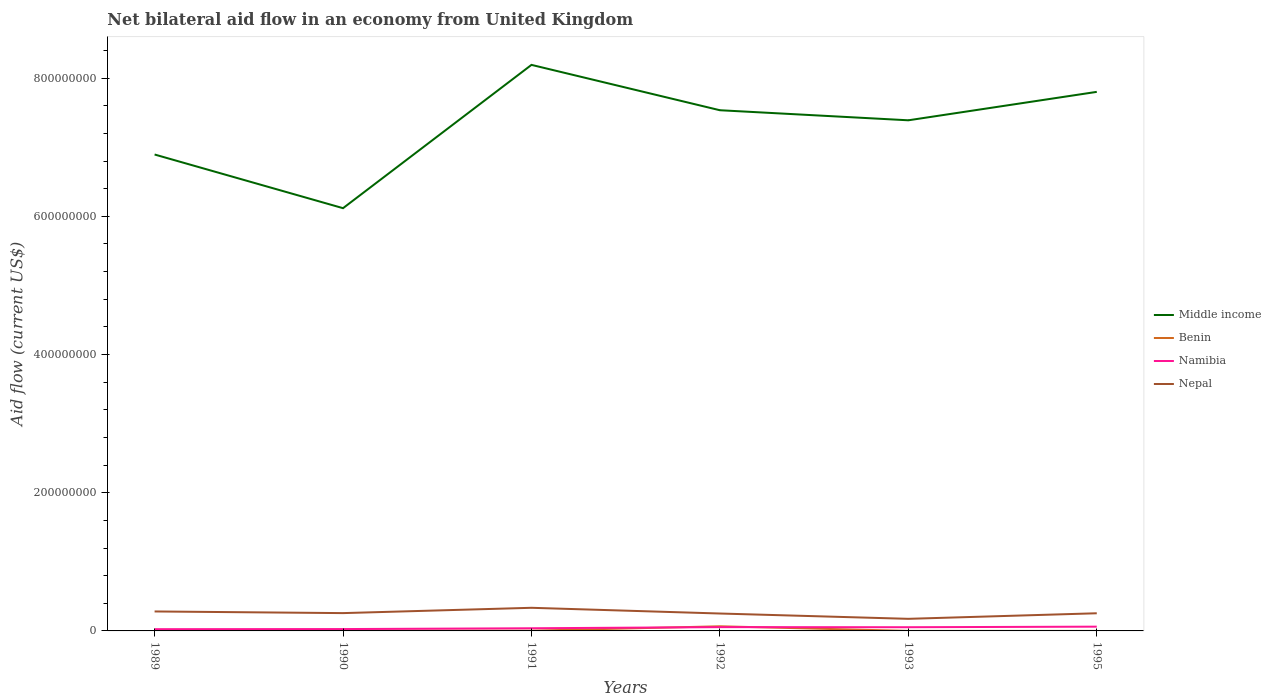How many different coloured lines are there?
Provide a short and direct response. 4. Across all years, what is the maximum net bilateral aid flow in Namibia?
Your response must be concise. 2.53e+06. In which year was the net bilateral aid flow in Benin maximum?
Your answer should be compact. 1995. What is the difference between the highest and the second highest net bilateral aid flow in Nepal?
Give a very brief answer. 1.60e+07. What is the difference between the highest and the lowest net bilateral aid flow in Middle income?
Offer a terse response. 4. What is the difference between two consecutive major ticks on the Y-axis?
Your response must be concise. 2.00e+08. Are the values on the major ticks of Y-axis written in scientific E-notation?
Keep it short and to the point. No. Does the graph contain any zero values?
Provide a succinct answer. No. Does the graph contain grids?
Provide a succinct answer. No. Where does the legend appear in the graph?
Make the answer very short. Center right. How many legend labels are there?
Ensure brevity in your answer.  4. How are the legend labels stacked?
Your response must be concise. Vertical. What is the title of the graph?
Your response must be concise. Net bilateral aid flow in an economy from United Kingdom. Does "Togo" appear as one of the legend labels in the graph?
Provide a succinct answer. No. What is the label or title of the X-axis?
Make the answer very short. Years. What is the label or title of the Y-axis?
Offer a terse response. Aid flow (current US$). What is the Aid flow (current US$) in Middle income in 1989?
Your response must be concise. 6.89e+08. What is the Aid flow (current US$) of Benin in 1989?
Make the answer very short. 5.40e+05. What is the Aid flow (current US$) of Namibia in 1989?
Make the answer very short. 2.53e+06. What is the Aid flow (current US$) of Nepal in 1989?
Your response must be concise. 2.82e+07. What is the Aid flow (current US$) of Middle income in 1990?
Your answer should be very brief. 6.12e+08. What is the Aid flow (current US$) of Benin in 1990?
Provide a short and direct response. 5.60e+05. What is the Aid flow (current US$) in Namibia in 1990?
Offer a terse response. 2.70e+06. What is the Aid flow (current US$) of Nepal in 1990?
Your answer should be compact. 2.58e+07. What is the Aid flow (current US$) of Middle income in 1991?
Your answer should be compact. 8.19e+08. What is the Aid flow (current US$) of Benin in 1991?
Give a very brief answer. 3.40e+05. What is the Aid flow (current US$) in Namibia in 1991?
Make the answer very short. 3.85e+06. What is the Aid flow (current US$) in Nepal in 1991?
Your answer should be very brief. 3.35e+07. What is the Aid flow (current US$) of Middle income in 1992?
Ensure brevity in your answer.  7.54e+08. What is the Aid flow (current US$) of Benin in 1992?
Offer a terse response. 6.70e+06. What is the Aid flow (current US$) of Namibia in 1992?
Ensure brevity in your answer.  5.49e+06. What is the Aid flow (current US$) in Nepal in 1992?
Your answer should be very brief. 2.52e+07. What is the Aid flow (current US$) in Middle income in 1993?
Offer a terse response. 7.39e+08. What is the Aid flow (current US$) in Namibia in 1993?
Your answer should be compact. 5.35e+06. What is the Aid flow (current US$) of Nepal in 1993?
Your answer should be compact. 1.75e+07. What is the Aid flow (current US$) of Middle income in 1995?
Your response must be concise. 7.80e+08. What is the Aid flow (current US$) of Namibia in 1995?
Make the answer very short. 6.18e+06. What is the Aid flow (current US$) of Nepal in 1995?
Ensure brevity in your answer.  2.56e+07. Across all years, what is the maximum Aid flow (current US$) of Middle income?
Provide a succinct answer. 8.19e+08. Across all years, what is the maximum Aid flow (current US$) in Benin?
Offer a terse response. 6.70e+06. Across all years, what is the maximum Aid flow (current US$) in Namibia?
Your answer should be very brief. 6.18e+06. Across all years, what is the maximum Aid flow (current US$) in Nepal?
Keep it short and to the point. 3.35e+07. Across all years, what is the minimum Aid flow (current US$) in Middle income?
Offer a terse response. 6.12e+08. Across all years, what is the minimum Aid flow (current US$) in Namibia?
Make the answer very short. 2.53e+06. Across all years, what is the minimum Aid flow (current US$) of Nepal?
Make the answer very short. 1.75e+07. What is the total Aid flow (current US$) of Middle income in the graph?
Offer a very short reply. 4.39e+09. What is the total Aid flow (current US$) of Benin in the graph?
Your response must be concise. 8.21e+06. What is the total Aid flow (current US$) of Namibia in the graph?
Make the answer very short. 2.61e+07. What is the total Aid flow (current US$) of Nepal in the graph?
Keep it short and to the point. 1.56e+08. What is the difference between the Aid flow (current US$) of Middle income in 1989 and that in 1990?
Provide a short and direct response. 7.77e+07. What is the difference between the Aid flow (current US$) in Namibia in 1989 and that in 1990?
Provide a succinct answer. -1.70e+05. What is the difference between the Aid flow (current US$) of Nepal in 1989 and that in 1990?
Your answer should be very brief. 2.40e+06. What is the difference between the Aid flow (current US$) in Middle income in 1989 and that in 1991?
Give a very brief answer. -1.30e+08. What is the difference between the Aid flow (current US$) of Benin in 1989 and that in 1991?
Offer a very short reply. 2.00e+05. What is the difference between the Aid flow (current US$) in Namibia in 1989 and that in 1991?
Make the answer very short. -1.32e+06. What is the difference between the Aid flow (current US$) of Nepal in 1989 and that in 1991?
Your answer should be very brief. -5.29e+06. What is the difference between the Aid flow (current US$) of Middle income in 1989 and that in 1992?
Your answer should be compact. -6.41e+07. What is the difference between the Aid flow (current US$) of Benin in 1989 and that in 1992?
Offer a terse response. -6.16e+06. What is the difference between the Aid flow (current US$) of Namibia in 1989 and that in 1992?
Offer a very short reply. -2.96e+06. What is the difference between the Aid flow (current US$) in Middle income in 1989 and that in 1993?
Give a very brief answer. -4.95e+07. What is the difference between the Aid flow (current US$) of Namibia in 1989 and that in 1993?
Your answer should be very brief. -2.82e+06. What is the difference between the Aid flow (current US$) in Nepal in 1989 and that in 1993?
Your response must be concise. 1.07e+07. What is the difference between the Aid flow (current US$) of Middle income in 1989 and that in 1995?
Ensure brevity in your answer.  -9.06e+07. What is the difference between the Aid flow (current US$) in Benin in 1989 and that in 1995?
Keep it short and to the point. 5.20e+05. What is the difference between the Aid flow (current US$) in Namibia in 1989 and that in 1995?
Provide a short and direct response. -3.65e+06. What is the difference between the Aid flow (current US$) in Nepal in 1989 and that in 1995?
Your answer should be compact. 2.63e+06. What is the difference between the Aid flow (current US$) in Middle income in 1990 and that in 1991?
Offer a terse response. -2.07e+08. What is the difference between the Aid flow (current US$) in Benin in 1990 and that in 1991?
Offer a terse response. 2.20e+05. What is the difference between the Aid flow (current US$) of Namibia in 1990 and that in 1991?
Your response must be concise. -1.15e+06. What is the difference between the Aid flow (current US$) in Nepal in 1990 and that in 1991?
Provide a succinct answer. -7.69e+06. What is the difference between the Aid flow (current US$) of Middle income in 1990 and that in 1992?
Provide a short and direct response. -1.42e+08. What is the difference between the Aid flow (current US$) in Benin in 1990 and that in 1992?
Your response must be concise. -6.14e+06. What is the difference between the Aid flow (current US$) of Namibia in 1990 and that in 1992?
Provide a succinct answer. -2.79e+06. What is the difference between the Aid flow (current US$) of Nepal in 1990 and that in 1992?
Your answer should be compact. 6.00e+05. What is the difference between the Aid flow (current US$) in Middle income in 1990 and that in 1993?
Provide a short and direct response. -1.27e+08. What is the difference between the Aid flow (current US$) of Benin in 1990 and that in 1993?
Your answer should be compact. 5.10e+05. What is the difference between the Aid flow (current US$) in Namibia in 1990 and that in 1993?
Your answer should be compact. -2.65e+06. What is the difference between the Aid flow (current US$) of Nepal in 1990 and that in 1993?
Keep it short and to the point. 8.28e+06. What is the difference between the Aid flow (current US$) of Middle income in 1990 and that in 1995?
Your response must be concise. -1.68e+08. What is the difference between the Aid flow (current US$) of Benin in 1990 and that in 1995?
Make the answer very short. 5.40e+05. What is the difference between the Aid flow (current US$) in Namibia in 1990 and that in 1995?
Your answer should be compact. -3.48e+06. What is the difference between the Aid flow (current US$) of Nepal in 1990 and that in 1995?
Provide a short and direct response. 2.30e+05. What is the difference between the Aid flow (current US$) of Middle income in 1991 and that in 1992?
Make the answer very short. 6.56e+07. What is the difference between the Aid flow (current US$) of Benin in 1991 and that in 1992?
Offer a terse response. -6.36e+06. What is the difference between the Aid flow (current US$) of Namibia in 1991 and that in 1992?
Ensure brevity in your answer.  -1.64e+06. What is the difference between the Aid flow (current US$) of Nepal in 1991 and that in 1992?
Give a very brief answer. 8.29e+06. What is the difference between the Aid flow (current US$) in Middle income in 1991 and that in 1993?
Keep it short and to the point. 8.02e+07. What is the difference between the Aid flow (current US$) in Benin in 1991 and that in 1993?
Your answer should be very brief. 2.90e+05. What is the difference between the Aid flow (current US$) of Namibia in 1991 and that in 1993?
Keep it short and to the point. -1.50e+06. What is the difference between the Aid flow (current US$) in Nepal in 1991 and that in 1993?
Keep it short and to the point. 1.60e+07. What is the difference between the Aid flow (current US$) of Middle income in 1991 and that in 1995?
Offer a very short reply. 3.91e+07. What is the difference between the Aid flow (current US$) of Benin in 1991 and that in 1995?
Ensure brevity in your answer.  3.20e+05. What is the difference between the Aid flow (current US$) of Namibia in 1991 and that in 1995?
Give a very brief answer. -2.33e+06. What is the difference between the Aid flow (current US$) in Nepal in 1991 and that in 1995?
Offer a terse response. 7.92e+06. What is the difference between the Aid flow (current US$) of Middle income in 1992 and that in 1993?
Offer a very short reply. 1.46e+07. What is the difference between the Aid flow (current US$) in Benin in 1992 and that in 1993?
Your response must be concise. 6.65e+06. What is the difference between the Aid flow (current US$) in Namibia in 1992 and that in 1993?
Give a very brief answer. 1.40e+05. What is the difference between the Aid flow (current US$) in Nepal in 1992 and that in 1993?
Your response must be concise. 7.68e+06. What is the difference between the Aid flow (current US$) of Middle income in 1992 and that in 1995?
Your answer should be very brief. -2.66e+07. What is the difference between the Aid flow (current US$) in Benin in 1992 and that in 1995?
Give a very brief answer. 6.68e+06. What is the difference between the Aid flow (current US$) of Namibia in 1992 and that in 1995?
Provide a succinct answer. -6.90e+05. What is the difference between the Aid flow (current US$) of Nepal in 1992 and that in 1995?
Give a very brief answer. -3.70e+05. What is the difference between the Aid flow (current US$) in Middle income in 1993 and that in 1995?
Your answer should be very brief. -4.11e+07. What is the difference between the Aid flow (current US$) of Namibia in 1993 and that in 1995?
Offer a very short reply. -8.30e+05. What is the difference between the Aid flow (current US$) in Nepal in 1993 and that in 1995?
Give a very brief answer. -8.05e+06. What is the difference between the Aid flow (current US$) of Middle income in 1989 and the Aid flow (current US$) of Benin in 1990?
Your answer should be compact. 6.89e+08. What is the difference between the Aid flow (current US$) in Middle income in 1989 and the Aid flow (current US$) in Namibia in 1990?
Provide a short and direct response. 6.87e+08. What is the difference between the Aid flow (current US$) of Middle income in 1989 and the Aid flow (current US$) of Nepal in 1990?
Your answer should be compact. 6.64e+08. What is the difference between the Aid flow (current US$) in Benin in 1989 and the Aid flow (current US$) in Namibia in 1990?
Offer a very short reply. -2.16e+06. What is the difference between the Aid flow (current US$) of Benin in 1989 and the Aid flow (current US$) of Nepal in 1990?
Provide a short and direct response. -2.52e+07. What is the difference between the Aid flow (current US$) in Namibia in 1989 and the Aid flow (current US$) in Nepal in 1990?
Offer a very short reply. -2.32e+07. What is the difference between the Aid flow (current US$) in Middle income in 1989 and the Aid flow (current US$) in Benin in 1991?
Your response must be concise. 6.89e+08. What is the difference between the Aid flow (current US$) in Middle income in 1989 and the Aid flow (current US$) in Namibia in 1991?
Provide a succinct answer. 6.86e+08. What is the difference between the Aid flow (current US$) of Middle income in 1989 and the Aid flow (current US$) of Nepal in 1991?
Your answer should be very brief. 6.56e+08. What is the difference between the Aid flow (current US$) in Benin in 1989 and the Aid flow (current US$) in Namibia in 1991?
Provide a succinct answer. -3.31e+06. What is the difference between the Aid flow (current US$) in Benin in 1989 and the Aid flow (current US$) in Nepal in 1991?
Your answer should be very brief. -3.29e+07. What is the difference between the Aid flow (current US$) of Namibia in 1989 and the Aid flow (current US$) of Nepal in 1991?
Keep it short and to the point. -3.09e+07. What is the difference between the Aid flow (current US$) of Middle income in 1989 and the Aid flow (current US$) of Benin in 1992?
Offer a terse response. 6.83e+08. What is the difference between the Aid flow (current US$) of Middle income in 1989 and the Aid flow (current US$) of Namibia in 1992?
Provide a succinct answer. 6.84e+08. What is the difference between the Aid flow (current US$) of Middle income in 1989 and the Aid flow (current US$) of Nepal in 1992?
Keep it short and to the point. 6.64e+08. What is the difference between the Aid flow (current US$) of Benin in 1989 and the Aid flow (current US$) of Namibia in 1992?
Make the answer very short. -4.95e+06. What is the difference between the Aid flow (current US$) in Benin in 1989 and the Aid flow (current US$) in Nepal in 1992?
Make the answer very short. -2.46e+07. What is the difference between the Aid flow (current US$) of Namibia in 1989 and the Aid flow (current US$) of Nepal in 1992?
Keep it short and to the point. -2.26e+07. What is the difference between the Aid flow (current US$) in Middle income in 1989 and the Aid flow (current US$) in Benin in 1993?
Offer a terse response. 6.89e+08. What is the difference between the Aid flow (current US$) of Middle income in 1989 and the Aid flow (current US$) of Namibia in 1993?
Offer a very short reply. 6.84e+08. What is the difference between the Aid flow (current US$) in Middle income in 1989 and the Aid flow (current US$) in Nepal in 1993?
Your answer should be compact. 6.72e+08. What is the difference between the Aid flow (current US$) in Benin in 1989 and the Aid flow (current US$) in Namibia in 1993?
Your answer should be compact. -4.81e+06. What is the difference between the Aid flow (current US$) of Benin in 1989 and the Aid flow (current US$) of Nepal in 1993?
Ensure brevity in your answer.  -1.70e+07. What is the difference between the Aid flow (current US$) of Namibia in 1989 and the Aid flow (current US$) of Nepal in 1993?
Keep it short and to the point. -1.50e+07. What is the difference between the Aid flow (current US$) in Middle income in 1989 and the Aid flow (current US$) in Benin in 1995?
Give a very brief answer. 6.89e+08. What is the difference between the Aid flow (current US$) in Middle income in 1989 and the Aid flow (current US$) in Namibia in 1995?
Ensure brevity in your answer.  6.83e+08. What is the difference between the Aid flow (current US$) in Middle income in 1989 and the Aid flow (current US$) in Nepal in 1995?
Provide a short and direct response. 6.64e+08. What is the difference between the Aid flow (current US$) in Benin in 1989 and the Aid flow (current US$) in Namibia in 1995?
Provide a short and direct response. -5.64e+06. What is the difference between the Aid flow (current US$) in Benin in 1989 and the Aid flow (current US$) in Nepal in 1995?
Give a very brief answer. -2.50e+07. What is the difference between the Aid flow (current US$) in Namibia in 1989 and the Aid flow (current US$) in Nepal in 1995?
Offer a very short reply. -2.30e+07. What is the difference between the Aid flow (current US$) of Middle income in 1990 and the Aid flow (current US$) of Benin in 1991?
Make the answer very short. 6.11e+08. What is the difference between the Aid flow (current US$) of Middle income in 1990 and the Aid flow (current US$) of Namibia in 1991?
Provide a short and direct response. 6.08e+08. What is the difference between the Aid flow (current US$) of Middle income in 1990 and the Aid flow (current US$) of Nepal in 1991?
Your response must be concise. 5.78e+08. What is the difference between the Aid flow (current US$) of Benin in 1990 and the Aid flow (current US$) of Namibia in 1991?
Offer a very short reply. -3.29e+06. What is the difference between the Aid flow (current US$) of Benin in 1990 and the Aid flow (current US$) of Nepal in 1991?
Offer a terse response. -3.29e+07. What is the difference between the Aid flow (current US$) in Namibia in 1990 and the Aid flow (current US$) in Nepal in 1991?
Offer a very short reply. -3.08e+07. What is the difference between the Aid flow (current US$) of Middle income in 1990 and the Aid flow (current US$) of Benin in 1992?
Offer a very short reply. 6.05e+08. What is the difference between the Aid flow (current US$) in Middle income in 1990 and the Aid flow (current US$) in Namibia in 1992?
Offer a terse response. 6.06e+08. What is the difference between the Aid flow (current US$) in Middle income in 1990 and the Aid flow (current US$) in Nepal in 1992?
Give a very brief answer. 5.87e+08. What is the difference between the Aid flow (current US$) in Benin in 1990 and the Aid flow (current US$) in Namibia in 1992?
Provide a succinct answer. -4.93e+06. What is the difference between the Aid flow (current US$) of Benin in 1990 and the Aid flow (current US$) of Nepal in 1992?
Make the answer very short. -2.46e+07. What is the difference between the Aid flow (current US$) of Namibia in 1990 and the Aid flow (current US$) of Nepal in 1992?
Keep it short and to the point. -2.25e+07. What is the difference between the Aid flow (current US$) in Middle income in 1990 and the Aid flow (current US$) in Benin in 1993?
Ensure brevity in your answer.  6.12e+08. What is the difference between the Aid flow (current US$) of Middle income in 1990 and the Aid flow (current US$) of Namibia in 1993?
Your answer should be very brief. 6.06e+08. What is the difference between the Aid flow (current US$) of Middle income in 1990 and the Aid flow (current US$) of Nepal in 1993?
Your response must be concise. 5.94e+08. What is the difference between the Aid flow (current US$) in Benin in 1990 and the Aid flow (current US$) in Namibia in 1993?
Offer a terse response. -4.79e+06. What is the difference between the Aid flow (current US$) of Benin in 1990 and the Aid flow (current US$) of Nepal in 1993?
Give a very brief answer. -1.69e+07. What is the difference between the Aid flow (current US$) of Namibia in 1990 and the Aid flow (current US$) of Nepal in 1993?
Make the answer very short. -1.48e+07. What is the difference between the Aid flow (current US$) in Middle income in 1990 and the Aid flow (current US$) in Benin in 1995?
Give a very brief answer. 6.12e+08. What is the difference between the Aid flow (current US$) of Middle income in 1990 and the Aid flow (current US$) of Namibia in 1995?
Provide a succinct answer. 6.06e+08. What is the difference between the Aid flow (current US$) in Middle income in 1990 and the Aid flow (current US$) in Nepal in 1995?
Make the answer very short. 5.86e+08. What is the difference between the Aid flow (current US$) of Benin in 1990 and the Aid flow (current US$) of Namibia in 1995?
Your answer should be compact. -5.62e+06. What is the difference between the Aid flow (current US$) in Benin in 1990 and the Aid flow (current US$) in Nepal in 1995?
Provide a short and direct response. -2.50e+07. What is the difference between the Aid flow (current US$) in Namibia in 1990 and the Aid flow (current US$) in Nepal in 1995?
Provide a succinct answer. -2.28e+07. What is the difference between the Aid flow (current US$) in Middle income in 1991 and the Aid flow (current US$) in Benin in 1992?
Offer a terse response. 8.12e+08. What is the difference between the Aid flow (current US$) of Middle income in 1991 and the Aid flow (current US$) of Namibia in 1992?
Provide a short and direct response. 8.14e+08. What is the difference between the Aid flow (current US$) of Middle income in 1991 and the Aid flow (current US$) of Nepal in 1992?
Give a very brief answer. 7.94e+08. What is the difference between the Aid flow (current US$) in Benin in 1991 and the Aid flow (current US$) in Namibia in 1992?
Offer a terse response. -5.15e+06. What is the difference between the Aid flow (current US$) in Benin in 1991 and the Aid flow (current US$) in Nepal in 1992?
Offer a terse response. -2.48e+07. What is the difference between the Aid flow (current US$) of Namibia in 1991 and the Aid flow (current US$) of Nepal in 1992?
Provide a succinct answer. -2.13e+07. What is the difference between the Aid flow (current US$) of Middle income in 1991 and the Aid flow (current US$) of Benin in 1993?
Keep it short and to the point. 8.19e+08. What is the difference between the Aid flow (current US$) in Middle income in 1991 and the Aid flow (current US$) in Namibia in 1993?
Your answer should be compact. 8.14e+08. What is the difference between the Aid flow (current US$) of Middle income in 1991 and the Aid flow (current US$) of Nepal in 1993?
Provide a succinct answer. 8.02e+08. What is the difference between the Aid flow (current US$) of Benin in 1991 and the Aid flow (current US$) of Namibia in 1993?
Make the answer very short. -5.01e+06. What is the difference between the Aid flow (current US$) in Benin in 1991 and the Aid flow (current US$) in Nepal in 1993?
Your answer should be very brief. -1.72e+07. What is the difference between the Aid flow (current US$) in Namibia in 1991 and the Aid flow (current US$) in Nepal in 1993?
Your answer should be very brief. -1.36e+07. What is the difference between the Aid flow (current US$) in Middle income in 1991 and the Aid flow (current US$) in Benin in 1995?
Provide a succinct answer. 8.19e+08. What is the difference between the Aid flow (current US$) in Middle income in 1991 and the Aid flow (current US$) in Namibia in 1995?
Your response must be concise. 8.13e+08. What is the difference between the Aid flow (current US$) in Middle income in 1991 and the Aid flow (current US$) in Nepal in 1995?
Offer a very short reply. 7.94e+08. What is the difference between the Aid flow (current US$) in Benin in 1991 and the Aid flow (current US$) in Namibia in 1995?
Your response must be concise. -5.84e+06. What is the difference between the Aid flow (current US$) in Benin in 1991 and the Aid flow (current US$) in Nepal in 1995?
Ensure brevity in your answer.  -2.52e+07. What is the difference between the Aid flow (current US$) of Namibia in 1991 and the Aid flow (current US$) of Nepal in 1995?
Offer a very short reply. -2.17e+07. What is the difference between the Aid flow (current US$) in Middle income in 1992 and the Aid flow (current US$) in Benin in 1993?
Your response must be concise. 7.53e+08. What is the difference between the Aid flow (current US$) in Middle income in 1992 and the Aid flow (current US$) in Namibia in 1993?
Your answer should be compact. 7.48e+08. What is the difference between the Aid flow (current US$) in Middle income in 1992 and the Aid flow (current US$) in Nepal in 1993?
Provide a short and direct response. 7.36e+08. What is the difference between the Aid flow (current US$) of Benin in 1992 and the Aid flow (current US$) of Namibia in 1993?
Give a very brief answer. 1.35e+06. What is the difference between the Aid flow (current US$) of Benin in 1992 and the Aid flow (current US$) of Nepal in 1993?
Offer a very short reply. -1.08e+07. What is the difference between the Aid flow (current US$) in Namibia in 1992 and the Aid flow (current US$) in Nepal in 1993?
Your answer should be compact. -1.20e+07. What is the difference between the Aid flow (current US$) in Middle income in 1992 and the Aid flow (current US$) in Benin in 1995?
Offer a very short reply. 7.54e+08. What is the difference between the Aid flow (current US$) in Middle income in 1992 and the Aid flow (current US$) in Namibia in 1995?
Provide a succinct answer. 7.47e+08. What is the difference between the Aid flow (current US$) of Middle income in 1992 and the Aid flow (current US$) of Nepal in 1995?
Provide a succinct answer. 7.28e+08. What is the difference between the Aid flow (current US$) in Benin in 1992 and the Aid flow (current US$) in Namibia in 1995?
Give a very brief answer. 5.20e+05. What is the difference between the Aid flow (current US$) in Benin in 1992 and the Aid flow (current US$) in Nepal in 1995?
Offer a terse response. -1.88e+07. What is the difference between the Aid flow (current US$) of Namibia in 1992 and the Aid flow (current US$) of Nepal in 1995?
Make the answer very short. -2.01e+07. What is the difference between the Aid flow (current US$) of Middle income in 1993 and the Aid flow (current US$) of Benin in 1995?
Provide a short and direct response. 7.39e+08. What is the difference between the Aid flow (current US$) of Middle income in 1993 and the Aid flow (current US$) of Namibia in 1995?
Offer a terse response. 7.33e+08. What is the difference between the Aid flow (current US$) of Middle income in 1993 and the Aid flow (current US$) of Nepal in 1995?
Provide a succinct answer. 7.13e+08. What is the difference between the Aid flow (current US$) in Benin in 1993 and the Aid flow (current US$) in Namibia in 1995?
Make the answer very short. -6.13e+06. What is the difference between the Aid flow (current US$) of Benin in 1993 and the Aid flow (current US$) of Nepal in 1995?
Keep it short and to the point. -2.55e+07. What is the difference between the Aid flow (current US$) in Namibia in 1993 and the Aid flow (current US$) in Nepal in 1995?
Offer a terse response. -2.02e+07. What is the average Aid flow (current US$) of Middle income per year?
Provide a succinct answer. 7.32e+08. What is the average Aid flow (current US$) of Benin per year?
Make the answer very short. 1.37e+06. What is the average Aid flow (current US$) in Namibia per year?
Your answer should be compact. 4.35e+06. What is the average Aid flow (current US$) of Nepal per year?
Provide a succinct answer. 2.59e+07. In the year 1989, what is the difference between the Aid flow (current US$) in Middle income and Aid flow (current US$) in Benin?
Keep it short and to the point. 6.89e+08. In the year 1989, what is the difference between the Aid flow (current US$) of Middle income and Aid flow (current US$) of Namibia?
Offer a very short reply. 6.87e+08. In the year 1989, what is the difference between the Aid flow (current US$) of Middle income and Aid flow (current US$) of Nepal?
Give a very brief answer. 6.61e+08. In the year 1989, what is the difference between the Aid flow (current US$) of Benin and Aid flow (current US$) of Namibia?
Give a very brief answer. -1.99e+06. In the year 1989, what is the difference between the Aid flow (current US$) of Benin and Aid flow (current US$) of Nepal?
Your answer should be compact. -2.76e+07. In the year 1989, what is the difference between the Aid flow (current US$) in Namibia and Aid flow (current US$) in Nepal?
Your answer should be very brief. -2.56e+07. In the year 1990, what is the difference between the Aid flow (current US$) in Middle income and Aid flow (current US$) in Benin?
Give a very brief answer. 6.11e+08. In the year 1990, what is the difference between the Aid flow (current US$) in Middle income and Aid flow (current US$) in Namibia?
Offer a very short reply. 6.09e+08. In the year 1990, what is the difference between the Aid flow (current US$) in Middle income and Aid flow (current US$) in Nepal?
Give a very brief answer. 5.86e+08. In the year 1990, what is the difference between the Aid flow (current US$) in Benin and Aid flow (current US$) in Namibia?
Your answer should be compact. -2.14e+06. In the year 1990, what is the difference between the Aid flow (current US$) in Benin and Aid flow (current US$) in Nepal?
Give a very brief answer. -2.52e+07. In the year 1990, what is the difference between the Aid flow (current US$) of Namibia and Aid flow (current US$) of Nepal?
Provide a short and direct response. -2.31e+07. In the year 1991, what is the difference between the Aid flow (current US$) of Middle income and Aid flow (current US$) of Benin?
Offer a terse response. 8.19e+08. In the year 1991, what is the difference between the Aid flow (current US$) of Middle income and Aid flow (current US$) of Namibia?
Your answer should be compact. 8.15e+08. In the year 1991, what is the difference between the Aid flow (current US$) in Middle income and Aid flow (current US$) in Nepal?
Make the answer very short. 7.86e+08. In the year 1991, what is the difference between the Aid flow (current US$) in Benin and Aid flow (current US$) in Namibia?
Make the answer very short. -3.51e+06. In the year 1991, what is the difference between the Aid flow (current US$) of Benin and Aid flow (current US$) of Nepal?
Offer a very short reply. -3.31e+07. In the year 1991, what is the difference between the Aid flow (current US$) of Namibia and Aid flow (current US$) of Nepal?
Keep it short and to the point. -2.96e+07. In the year 1992, what is the difference between the Aid flow (current US$) of Middle income and Aid flow (current US$) of Benin?
Keep it short and to the point. 7.47e+08. In the year 1992, what is the difference between the Aid flow (current US$) of Middle income and Aid flow (current US$) of Namibia?
Offer a terse response. 7.48e+08. In the year 1992, what is the difference between the Aid flow (current US$) of Middle income and Aid flow (current US$) of Nepal?
Ensure brevity in your answer.  7.28e+08. In the year 1992, what is the difference between the Aid flow (current US$) in Benin and Aid flow (current US$) in Namibia?
Your response must be concise. 1.21e+06. In the year 1992, what is the difference between the Aid flow (current US$) of Benin and Aid flow (current US$) of Nepal?
Provide a succinct answer. -1.85e+07. In the year 1992, what is the difference between the Aid flow (current US$) in Namibia and Aid flow (current US$) in Nepal?
Keep it short and to the point. -1.97e+07. In the year 1993, what is the difference between the Aid flow (current US$) of Middle income and Aid flow (current US$) of Benin?
Make the answer very short. 7.39e+08. In the year 1993, what is the difference between the Aid flow (current US$) in Middle income and Aid flow (current US$) in Namibia?
Your answer should be compact. 7.34e+08. In the year 1993, what is the difference between the Aid flow (current US$) in Middle income and Aid flow (current US$) in Nepal?
Provide a short and direct response. 7.21e+08. In the year 1993, what is the difference between the Aid flow (current US$) of Benin and Aid flow (current US$) of Namibia?
Offer a very short reply. -5.30e+06. In the year 1993, what is the difference between the Aid flow (current US$) of Benin and Aid flow (current US$) of Nepal?
Ensure brevity in your answer.  -1.74e+07. In the year 1993, what is the difference between the Aid flow (current US$) in Namibia and Aid flow (current US$) in Nepal?
Offer a very short reply. -1.22e+07. In the year 1995, what is the difference between the Aid flow (current US$) in Middle income and Aid flow (current US$) in Benin?
Offer a very short reply. 7.80e+08. In the year 1995, what is the difference between the Aid flow (current US$) in Middle income and Aid flow (current US$) in Namibia?
Your answer should be very brief. 7.74e+08. In the year 1995, what is the difference between the Aid flow (current US$) of Middle income and Aid flow (current US$) of Nepal?
Your answer should be very brief. 7.55e+08. In the year 1995, what is the difference between the Aid flow (current US$) in Benin and Aid flow (current US$) in Namibia?
Provide a succinct answer. -6.16e+06. In the year 1995, what is the difference between the Aid flow (current US$) in Benin and Aid flow (current US$) in Nepal?
Make the answer very short. -2.55e+07. In the year 1995, what is the difference between the Aid flow (current US$) of Namibia and Aid flow (current US$) of Nepal?
Offer a terse response. -1.94e+07. What is the ratio of the Aid flow (current US$) of Middle income in 1989 to that in 1990?
Your answer should be compact. 1.13. What is the ratio of the Aid flow (current US$) in Namibia in 1989 to that in 1990?
Your answer should be compact. 0.94. What is the ratio of the Aid flow (current US$) of Nepal in 1989 to that in 1990?
Keep it short and to the point. 1.09. What is the ratio of the Aid flow (current US$) in Middle income in 1989 to that in 1991?
Offer a very short reply. 0.84. What is the ratio of the Aid flow (current US$) of Benin in 1989 to that in 1991?
Give a very brief answer. 1.59. What is the ratio of the Aid flow (current US$) of Namibia in 1989 to that in 1991?
Make the answer very short. 0.66. What is the ratio of the Aid flow (current US$) in Nepal in 1989 to that in 1991?
Offer a terse response. 0.84. What is the ratio of the Aid flow (current US$) of Middle income in 1989 to that in 1992?
Your answer should be compact. 0.92. What is the ratio of the Aid flow (current US$) in Benin in 1989 to that in 1992?
Offer a terse response. 0.08. What is the ratio of the Aid flow (current US$) of Namibia in 1989 to that in 1992?
Your answer should be compact. 0.46. What is the ratio of the Aid flow (current US$) of Nepal in 1989 to that in 1992?
Make the answer very short. 1.12. What is the ratio of the Aid flow (current US$) in Middle income in 1989 to that in 1993?
Provide a succinct answer. 0.93. What is the ratio of the Aid flow (current US$) in Namibia in 1989 to that in 1993?
Offer a terse response. 0.47. What is the ratio of the Aid flow (current US$) of Nepal in 1989 to that in 1993?
Your answer should be compact. 1.61. What is the ratio of the Aid flow (current US$) of Middle income in 1989 to that in 1995?
Provide a succinct answer. 0.88. What is the ratio of the Aid flow (current US$) of Namibia in 1989 to that in 1995?
Make the answer very short. 0.41. What is the ratio of the Aid flow (current US$) in Nepal in 1989 to that in 1995?
Provide a short and direct response. 1.1. What is the ratio of the Aid flow (current US$) of Middle income in 1990 to that in 1991?
Offer a very short reply. 0.75. What is the ratio of the Aid flow (current US$) of Benin in 1990 to that in 1991?
Your response must be concise. 1.65. What is the ratio of the Aid flow (current US$) of Namibia in 1990 to that in 1991?
Your answer should be compact. 0.7. What is the ratio of the Aid flow (current US$) in Nepal in 1990 to that in 1991?
Keep it short and to the point. 0.77. What is the ratio of the Aid flow (current US$) in Middle income in 1990 to that in 1992?
Ensure brevity in your answer.  0.81. What is the ratio of the Aid flow (current US$) of Benin in 1990 to that in 1992?
Give a very brief answer. 0.08. What is the ratio of the Aid flow (current US$) of Namibia in 1990 to that in 1992?
Provide a succinct answer. 0.49. What is the ratio of the Aid flow (current US$) in Nepal in 1990 to that in 1992?
Provide a succinct answer. 1.02. What is the ratio of the Aid flow (current US$) of Middle income in 1990 to that in 1993?
Your response must be concise. 0.83. What is the ratio of the Aid flow (current US$) in Namibia in 1990 to that in 1993?
Offer a terse response. 0.5. What is the ratio of the Aid flow (current US$) in Nepal in 1990 to that in 1993?
Your response must be concise. 1.47. What is the ratio of the Aid flow (current US$) of Middle income in 1990 to that in 1995?
Keep it short and to the point. 0.78. What is the ratio of the Aid flow (current US$) of Benin in 1990 to that in 1995?
Keep it short and to the point. 28. What is the ratio of the Aid flow (current US$) of Namibia in 1990 to that in 1995?
Your response must be concise. 0.44. What is the ratio of the Aid flow (current US$) in Nepal in 1990 to that in 1995?
Your answer should be compact. 1.01. What is the ratio of the Aid flow (current US$) of Middle income in 1991 to that in 1992?
Provide a succinct answer. 1.09. What is the ratio of the Aid flow (current US$) of Benin in 1991 to that in 1992?
Offer a terse response. 0.05. What is the ratio of the Aid flow (current US$) in Namibia in 1991 to that in 1992?
Keep it short and to the point. 0.7. What is the ratio of the Aid flow (current US$) in Nepal in 1991 to that in 1992?
Ensure brevity in your answer.  1.33. What is the ratio of the Aid flow (current US$) in Middle income in 1991 to that in 1993?
Ensure brevity in your answer.  1.11. What is the ratio of the Aid flow (current US$) in Benin in 1991 to that in 1993?
Keep it short and to the point. 6.8. What is the ratio of the Aid flow (current US$) of Namibia in 1991 to that in 1993?
Your answer should be compact. 0.72. What is the ratio of the Aid flow (current US$) of Nepal in 1991 to that in 1993?
Offer a very short reply. 1.91. What is the ratio of the Aid flow (current US$) in Middle income in 1991 to that in 1995?
Your answer should be very brief. 1.05. What is the ratio of the Aid flow (current US$) of Benin in 1991 to that in 1995?
Provide a short and direct response. 17. What is the ratio of the Aid flow (current US$) of Namibia in 1991 to that in 1995?
Your response must be concise. 0.62. What is the ratio of the Aid flow (current US$) in Nepal in 1991 to that in 1995?
Ensure brevity in your answer.  1.31. What is the ratio of the Aid flow (current US$) of Middle income in 1992 to that in 1993?
Offer a terse response. 1.02. What is the ratio of the Aid flow (current US$) in Benin in 1992 to that in 1993?
Offer a terse response. 134. What is the ratio of the Aid flow (current US$) in Namibia in 1992 to that in 1993?
Your answer should be compact. 1.03. What is the ratio of the Aid flow (current US$) of Nepal in 1992 to that in 1993?
Keep it short and to the point. 1.44. What is the ratio of the Aid flow (current US$) in Middle income in 1992 to that in 1995?
Your response must be concise. 0.97. What is the ratio of the Aid flow (current US$) in Benin in 1992 to that in 1995?
Ensure brevity in your answer.  335. What is the ratio of the Aid flow (current US$) in Namibia in 1992 to that in 1995?
Offer a very short reply. 0.89. What is the ratio of the Aid flow (current US$) in Nepal in 1992 to that in 1995?
Provide a succinct answer. 0.99. What is the ratio of the Aid flow (current US$) in Middle income in 1993 to that in 1995?
Keep it short and to the point. 0.95. What is the ratio of the Aid flow (current US$) in Benin in 1993 to that in 1995?
Keep it short and to the point. 2.5. What is the ratio of the Aid flow (current US$) in Namibia in 1993 to that in 1995?
Make the answer very short. 0.87. What is the ratio of the Aid flow (current US$) of Nepal in 1993 to that in 1995?
Keep it short and to the point. 0.68. What is the difference between the highest and the second highest Aid flow (current US$) of Middle income?
Your response must be concise. 3.91e+07. What is the difference between the highest and the second highest Aid flow (current US$) in Benin?
Your answer should be compact. 6.14e+06. What is the difference between the highest and the second highest Aid flow (current US$) of Namibia?
Ensure brevity in your answer.  6.90e+05. What is the difference between the highest and the second highest Aid flow (current US$) in Nepal?
Your response must be concise. 5.29e+06. What is the difference between the highest and the lowest Aid flow (current US$) of Middle income?
Ensure brevity in your answer.  2.07e+08. What is the difference between the highest and the lowest Aid flow (current US$) in Benin?
Keep it short and to the point. 6.68e+06. What is the difference between the highest and the lowest Aid flow (current US$) of Namibia?
Offer a terse response. 3.65e+06. What is the difference between the highest and the lowest Aid flow (current US$) of Nepal?
Offer a very short reply. 1.60e+07. 